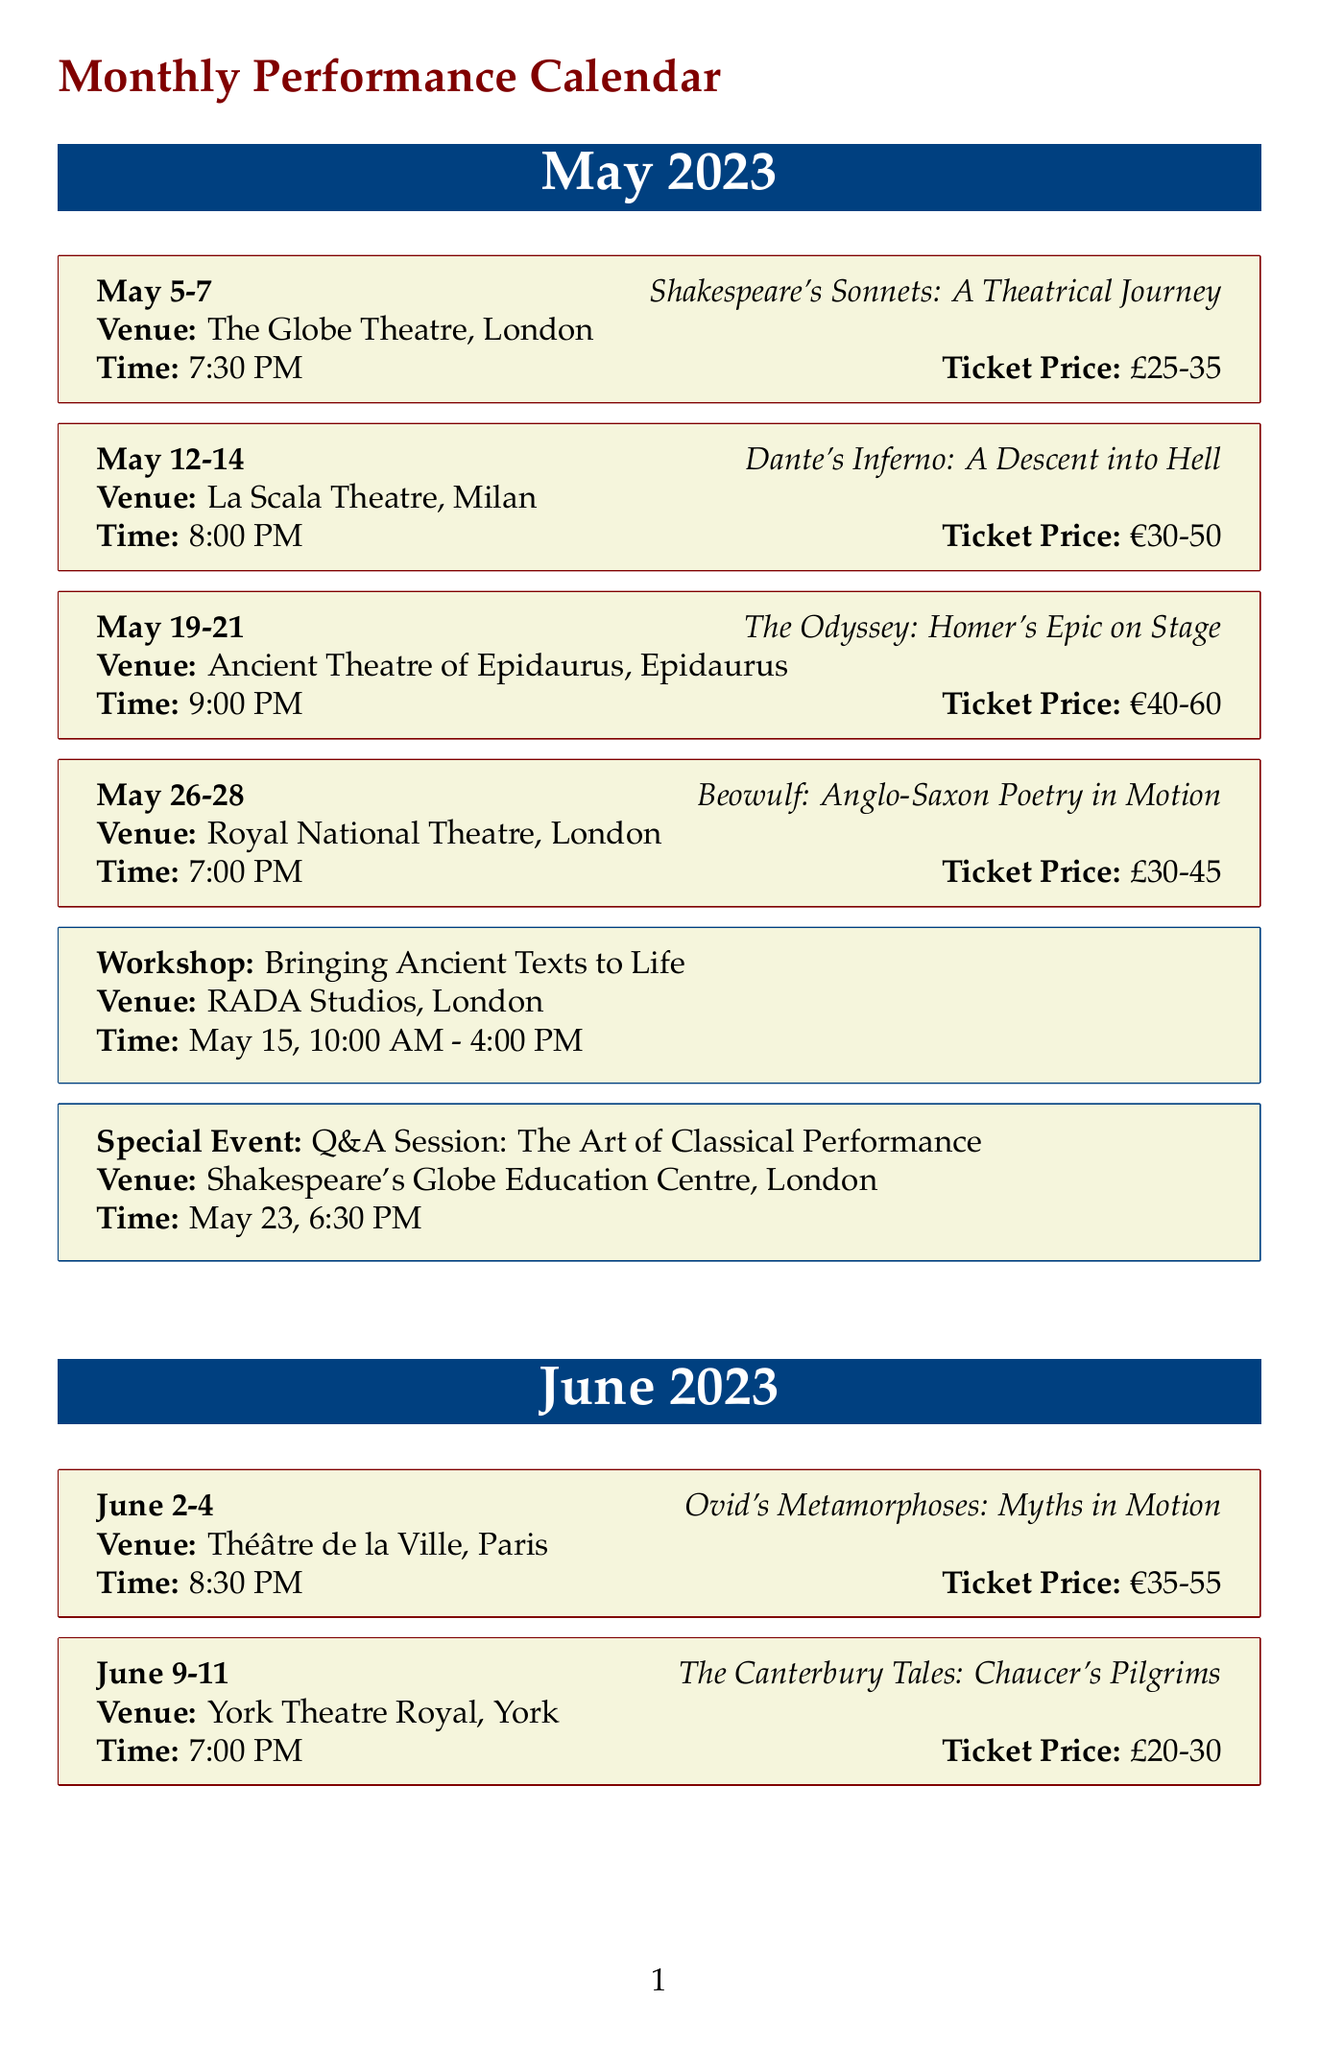What show is scheduled for June 2-4? The show scheduled for that date is listed in the document under the performances for June.
Answer: Ovid's Metamorphoses: Myths in Motion What is the ticket price range for "Dante's Inferno"? The document specifies the ticket price range for the show "Dante's Inferno" under its respective performance details.
Answer: €30-50 Where is "The Divine Comedy" being performed? The venue for "The Divine Comedy" is mentioned in the June performance section of the document.
Answer: Teatro della Pergola What is the date and time of the workshop on May 15? The document outlines the workshop details along with its date and time.
Answer: May 15, 10:00 AM - 4:00 PM In which city is the Q&A session taking place? The city for the Q&A session is provided in the special events section of the document.
Answer: London How many performances are there in May 2023? To determine the number of performances, count the entries listed under the May 2023 performances section in the document.
Answer: 4 What is the admission fee for the lecture on June 30? The admission fee is stated directly in the details of the special event for the lecture in June.
Answer: €10 Which venue hosts "Beowulf"? The document specifies the venue where "Beowulf" will be performed within the May performances.
Answer: Royal National Theatre What workshop takes place on June 20? The workshop title is provided in the document within the June workshops section.
Answer: Physical Theatre and Classical Texts 